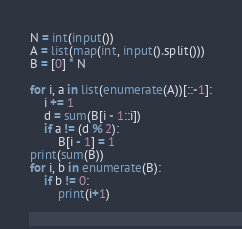Convert code to text. <code><loc_0><loc_0><loc_500><loc_500><_Python_>N = int(input())
A = list(map(int, input().split()))
B = [0] * N

for i, a in list(enumerate(A))[::-1]:
    i += 1
    d = sum(B[i - 1::i])
    if a != (d % 2):
        B[i - 1] = 1
print(sum(B))
for i, b in enumerate(B):
    if b != 0:
        print(i+1)
</code> 